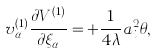Convert formula to latex. <formula><loc_0><loc_0><loc_500><loc_500>v ^ { ( 1 ) } _ { \alpha } \frac { \partial V ^ { ( 1 ) } } { \partial \xi _ { \alpha } } = + \frac { 1 } { 4 \lambda } a _ { i } ^ { 2 } \theta ,</formula> 